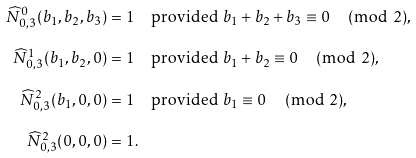Convert formula to latex. <formula><loc_0><loc_0><loc_500><loc_500>\widehat { N } _ { 0 , 3 } ^ { 0 } ( b _ { 1 } , b _ { 2 } , b _ { 3 } ) & = 1 \quad \text {provided } b _ { 1 } + b _ { 2 } + b _ { 3 } \equiv 0 \, \pmod { 2 } , \\ \widehat { N } _ { 0 , 3 } ^ { 1 } ( b _ { 1 } , b _ { 2 } , 0 ) & = 1 \quad \text {provided } b _ { 1 } + b _ { 2 } \equiv 0 \, \pmod { 2 } , \\ \widehat { N } _ { 0 , 3 } ^ { 2 } ( b _ { 1 } , 0 , 0 ) & = 1 \quad \text {provided } b _ { 1 } \equiv 0 \, \pmod { 2 } , \\ \widehat { N } _ { 0 , 3 } ^ { 2 } ( 0 , 0 , 0 ) & = 1 .</formula> 